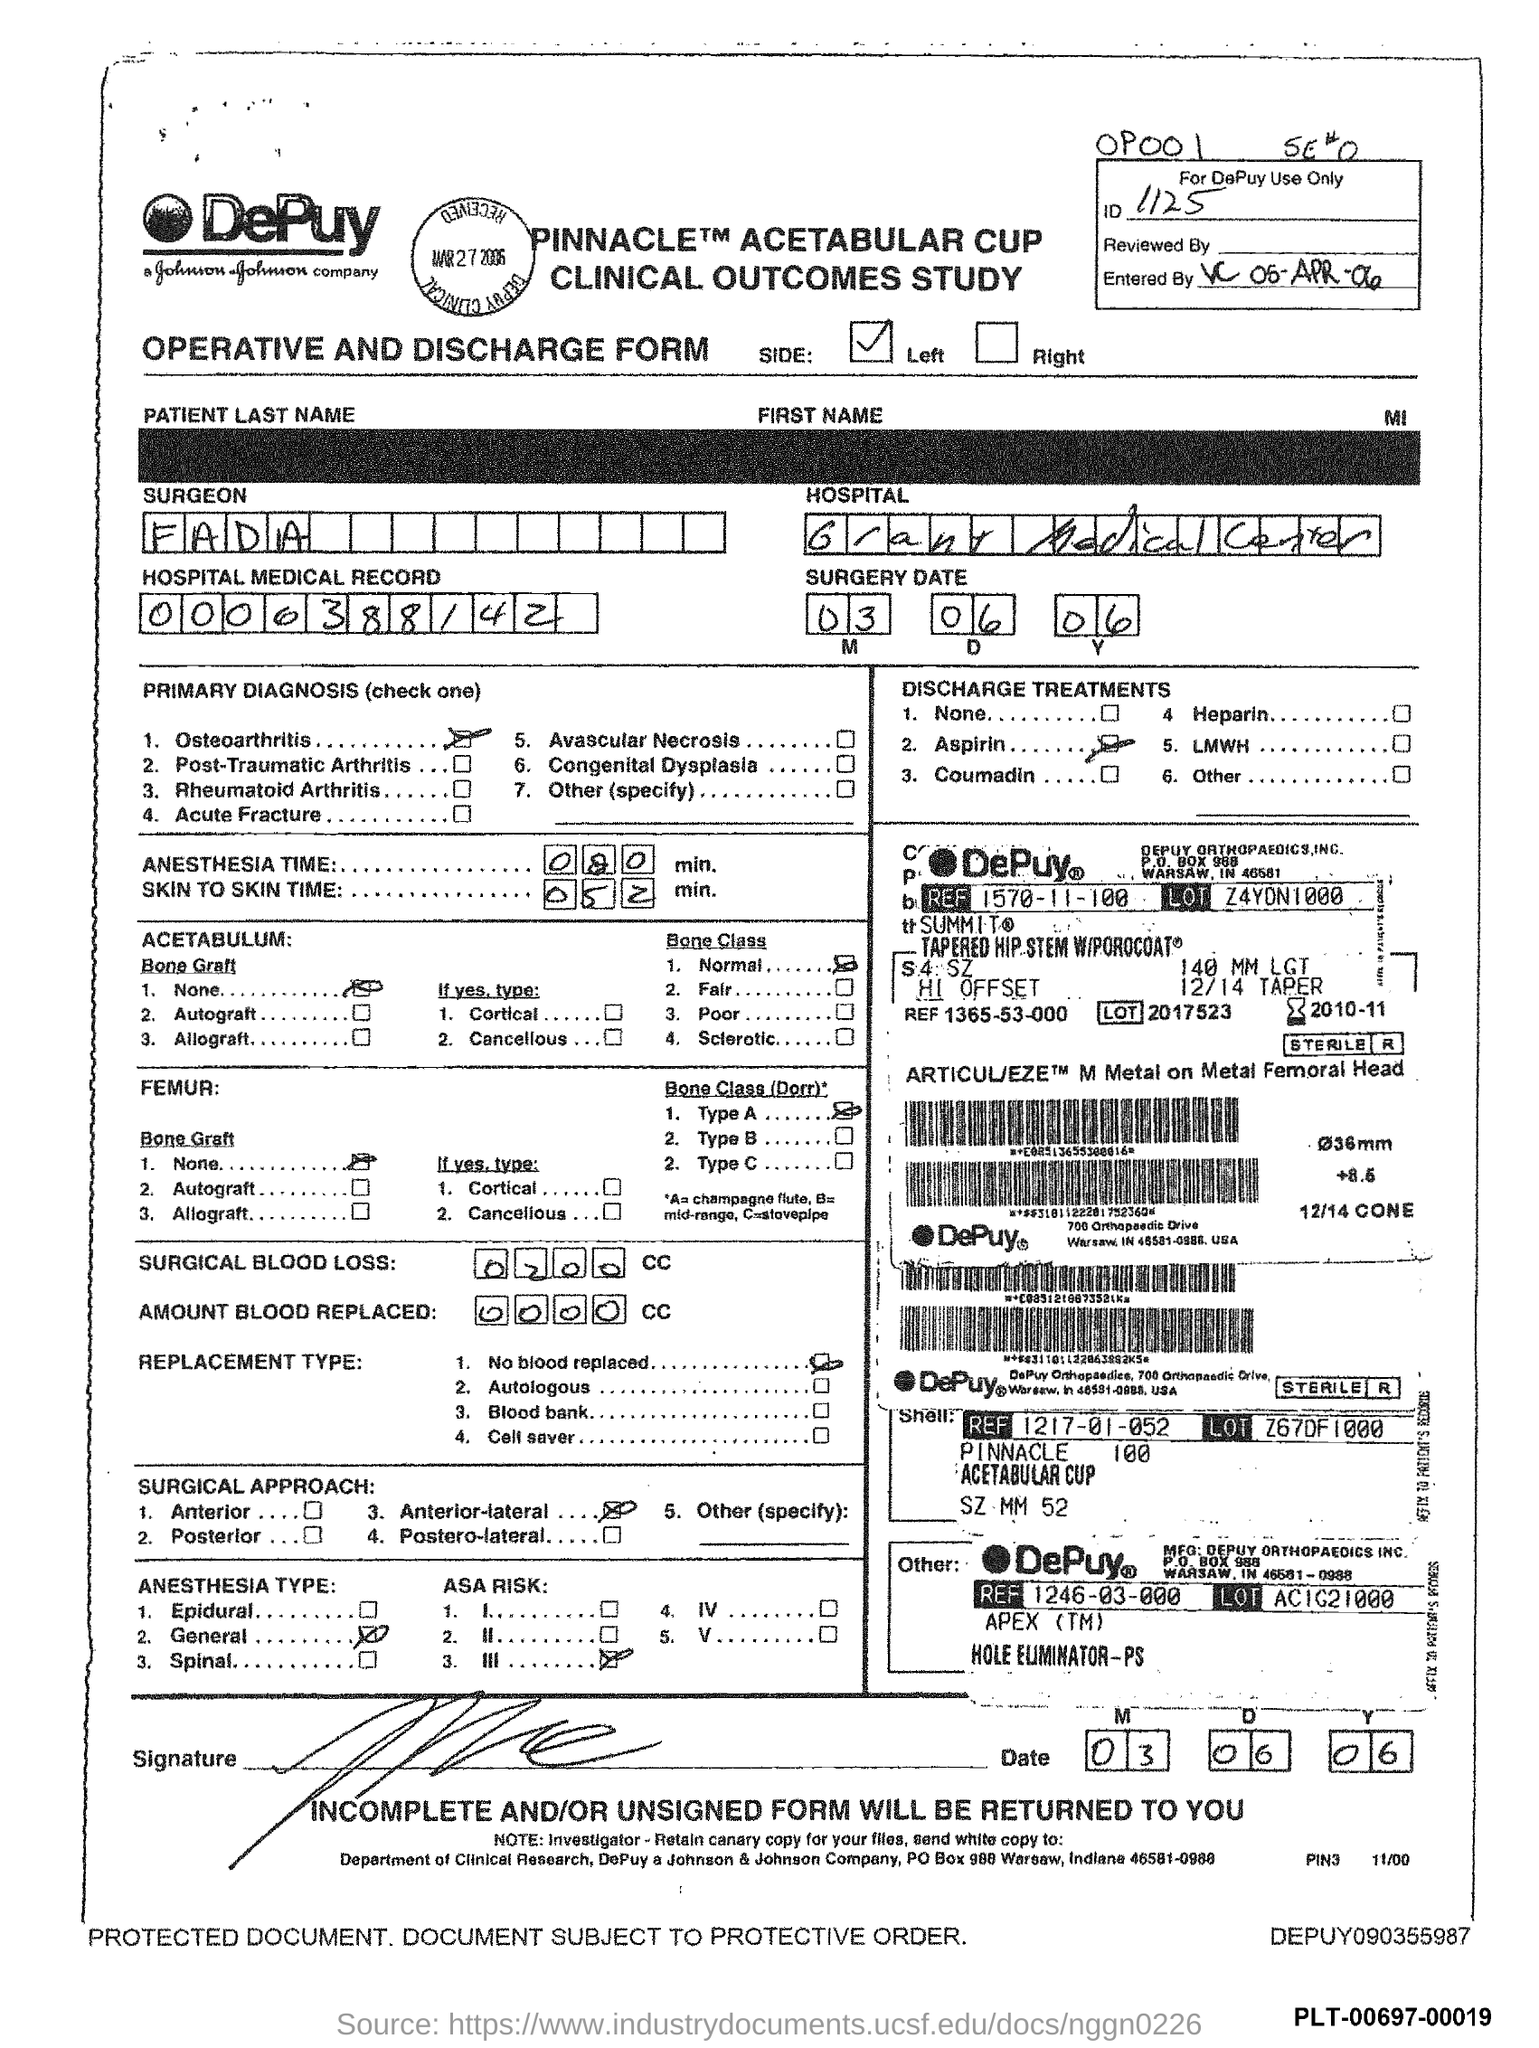What is the ID Number?
Keep it short and to the point. 1125. What is the name of the Surgeon?
Your answer should be very brief. Fada. 